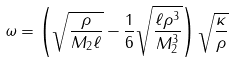Convert formula to latex. <formula><loc_0><loc_0><loc_500><loc_500>\omega = \left ( \sqrt { \frac { \rho } { M _ { 2 } \ell } } - \frac { 1 } { 6 } \sqrt { \frac { \ell \rho ^ { 3 } } { M _ { 2 } ^ { 3 } } } \right ) \sqrt { \frac { \kappa } { \rho } }</formula> 